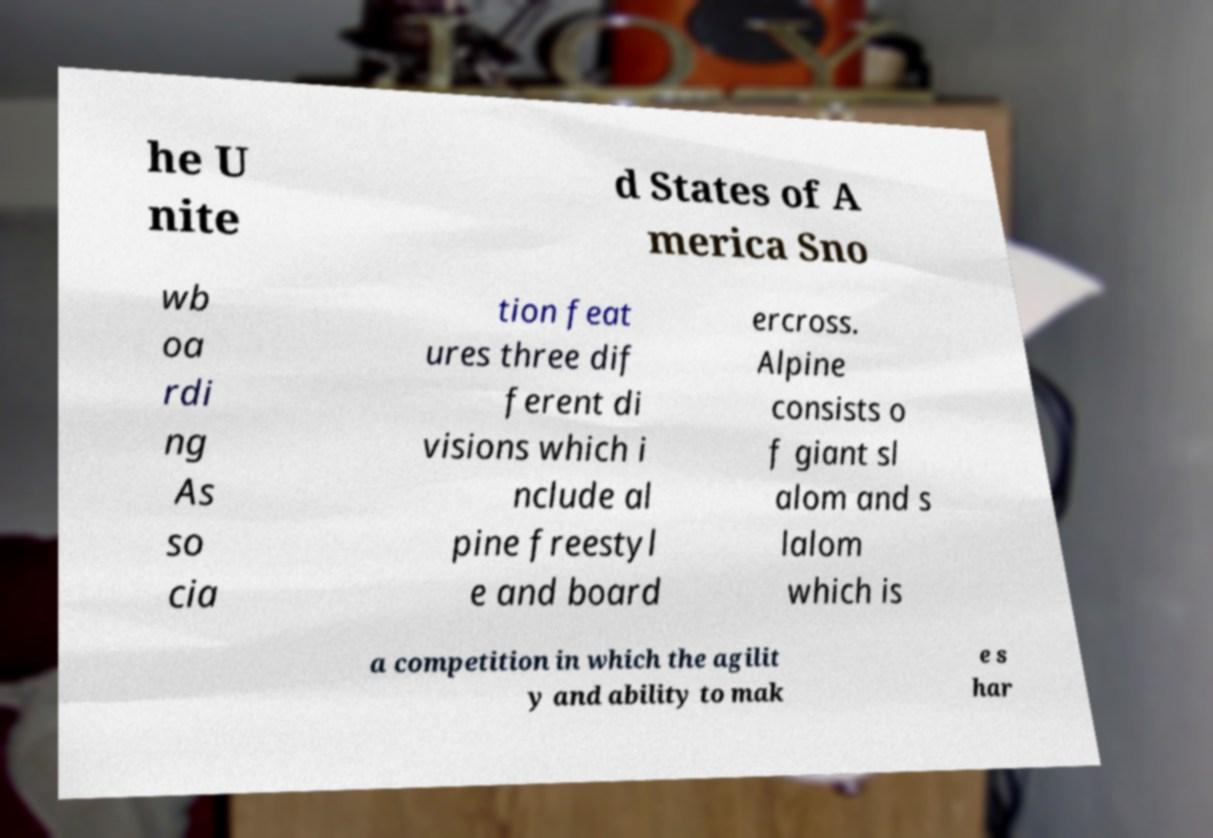Please read and relay the text visible in this image. What does it say? he U nite d States of A merica Sno wb oa rdi ng As so cia tion feat ures three dif ferent di visions which i nclude al pine freestyl e and board ercross. Alpine consists o f giant sl alom and s lalom which is a competition in which the agilit y and ability to mak e s har 